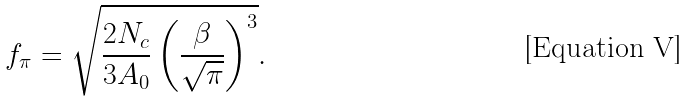Convert formula to latex. <formula><loc_0><loc_0><loc_500><loc_500>f _ { \pi } = \sqrt { \frac { 2 N _ { c } } { 3 A _ { 0 } } \left ( \frac { \beta } { \sqrt { \pi } } \right ) ^ { 3 } } .</formula> 